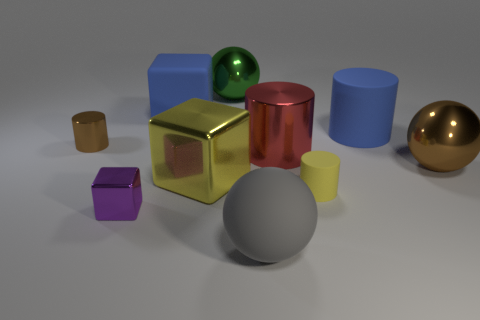Subtract all cubes. How many objects are left? 7 Subtract all red metallic objects. Subtract all small yellow cylinders. How many objects are left? 8 Add 8 yellow cubes. How many yellow cubes are left? 9 Add 6 metallic cylinders. How many metallic cylinders exist? 8 Subtract 0 brown cubes. How many objects are left? 10 